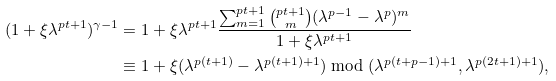<formula> <loc_0><loc_0><loc_500><loc_500>( 1 + \xi \lambda ^ { p t + 1 } ) ^ { \gamma - 1 } & = 1 + \xi \lambda ^ { p t + 1 } \frac { \sum _ { m = 1 } ^ { p t + 1 } \binom { p t + 1 } { m } ( \lambda ^ { p - 1 } - \lambda ^ { p } ) ^ { m } } { 1 + \xi \lambda ^ { p t + 1 } } \\ & \equiv 1 + \xi ( \lambda ^ { p ( t + 1 ) } - \lambda ^ { p ( t + 1 ) + 1 } ) \bmod ( \lambda ^ { p ( t + p - 1 ) + 1 } , \lambda ^ { p ( 2 t + 1 ) + 1 } ) ,</formula> 